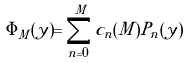Convert formula to latex. <formula><loc_0><loc_0><loc_500><loc_500>\Phi _ { M } ( y ) = \sum _ { n = 0 } ^ { M } c _ { n } ( M ) P _ { n } ( y )</formula> 